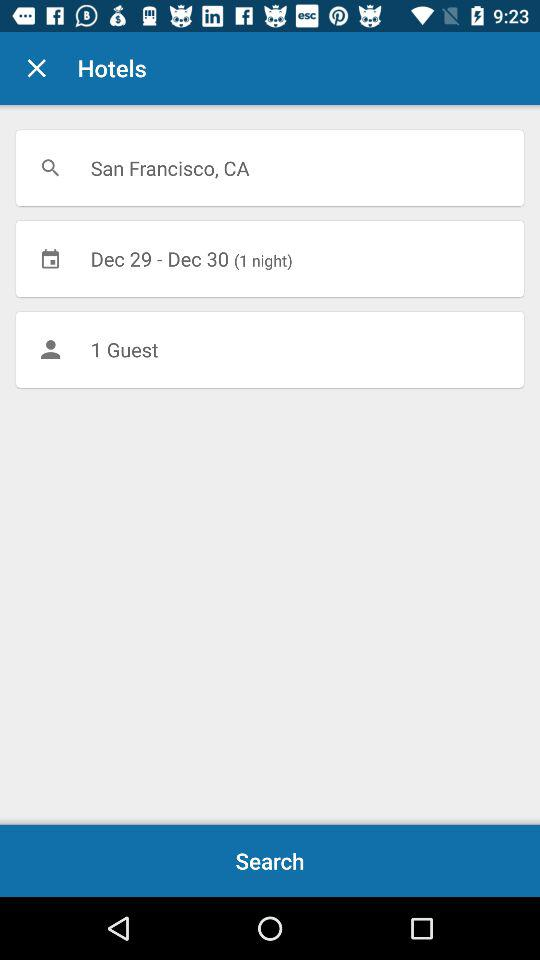For how many nights is the hotel being searched? The hotel is being searched for 1 night. 